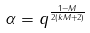Convert formula to latex. <formula><loc_0><loc_0><loc_500><loc_500>\alpha = q ^ { \frac { 1 - M } { 2 ( k M + 2 ) } }</formula> 